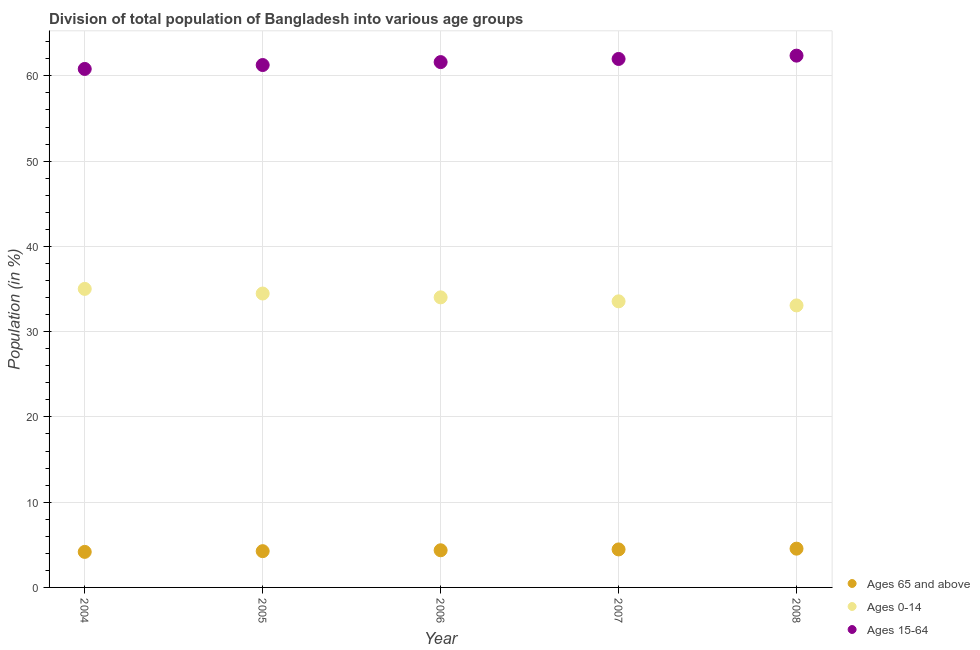How many different coloured dotlines are there?
Offer a very short reply. 3. Is the number of dotlines equal to the number of legend labels?
Keep it short and to the point. Yes. What is the percentage of population within the age-group 0-14 in 2007?
Your answer should be very brief. 33.56. Across all years, what is the maximum percentage of population within the age-group 15-64?
Offer a terse response. 62.38. Across all years, what is the minimum percentage of population within the age-group of 65 and above?
Your response must be concise. 4.17. In which year was the percentage of population within the age-group 15-64 maximum?
Offer a terse response. 2008. What is the total percentage of population within the age-group 0-14 in the graph?
Offer a very short reply. 170.15. What is the difference between the percentage of population within the age-group 0-14 in 2006 and that in 2007?
Your answer should be compact. 0.47. What is the difference between the percentage of population within the age-group 0-14 in 2006 and the percentage of population within the age-group of 65 and above in 2008?
Ensure brevity in your answer.  29.48. What is the average percentage of population within the age-group of 65 and above per year?
Your answer should be compact. 4.36. In the year 2005, what is the difference between the percentage of population within the age-group 15-64 and percentage of population within the age-group of 65 and above?
Your answer should be very brief. 57.02. In how many years, is the percentage of population within the age-group 0-14 greater than 52 %?
Provide a succinct answer. 0. What is the ratio of the percentage of population within the age-group 0-14 in 2005 to that in 2007?
Keep it short and to the point. 1.03. Is the percentage of population within the age-group 15-64 in 2004 less than that in 2005?
Ensure brevity in your answer.  Yes. Is the difference between the percentage of population within the age-group of 65 and above in 2004 and 2007 greater than the difference between the percentage of population within the age-group 15-64 in 2004 and 2007?
Offer a very short reply. Yes. What is the difference between the highest and the second highest percentage of population within the age-group 15-64?
Your response must be concise. 0.39. What is the difference between the highest and the lowest percentage of population within the age-group of 65 and above?
Your response must be concise. 0.38. Does the percentage of population within the age-group 0-14 monotonically increase over the years?
Provide a short and direct response. No. How many years are there in the graph?
Your answer should be compact. 5. Are the values on the major ticks of Y-axis written in scientific E-notation?
Give a very brief answer. No. Does the graph contain any zero values?
Provide a short and direct response. No. Does the graph contain grids?
Your response must be concise. Yes. Where does the legend appear in the graph?
Keep it short and to the point. Bottom right. How are the legend labels stacked?
Provide a short and direct response. Vertical. What is the title of the graph?
Offer a terse response. Division of total population of Bangladesh into various age groups
. What is the label or title of the X-axis?
Offer a terse response. Year. What is the label or title of the Y-axis?
Make the answer very short. Population (in %). What is the Population (in %) in Ages 65 and above in 2004?
Your response must be concise. 4.17. What is the Population (in %) of Ages 0-14 in 2004?
Keep it short and to the point. 35.02. What is the Population (in %) of Ages 15-64 in 2004?
Give a very brief answer. 60.81. What is the Population (in %) in Ages 65 and above in 2005?
Make the answer very short. 4.25. What is the Population (in %) in Ages 0-14 in 2005?
Your answer should be compact. 34.47. What is the Population (in %) of Ages 15-64 in 2005?
Give a very brief answer. 61.27. What is the Population (in %) in Ages 65 and above in 2006?
Give a very brief answer. 4.36. What is the Population (in %) of Ages 0-14 in 2006?
Offer a very short reply. 34.02. What is the Population (in %) in Ages 15-64 in 2006?
Your response must be concise. 61.62. What is the Population (in %) of Ages 65 and above in 2007?
Give a very brief answer. 4.46. What is the Population (in %) of Ages 0-14 in 2007?
Offer a terse response. 33.56. What is the Population (in %) of Ages 15-64 in 2007?
Keep it short and to the point. 61.99. What is the Population (in %) of Ages 65 and above in 2008?
Your answer should be compact. 4.55. What is the Population (in %) in Ages 0-14 in 2008?
Provide a short and direct response. 33.08. What is the Population (in %) in Ages 15-64 in 2008?
Your response must be concise. 62.38. Across all years, what is the maximum Population (in %) of Ages 65 and above?
Your answer should be compact. 4.55. Across all years, what is the maximum Population (in %) in Ages 0-14?
Offer a very short reply. 35.02. Across all years, what is the maximum Population (in %) in Ages 15-64?
Make the answer very short. 62.38. Across all years, what is the minimum Population (in %) of Ages 65 and above?
Your answer should be compact. 4.17. Across all years, what is the minimum Population (in %) in Ages 0-14?
Give a very brief answer. 33.08. Across all years, what is the minimum Population (in %) in Ages 15-64?
Make the answer very short. 60.81. What is the total Population (in %) in Ages 65 and above in the graph?
Give a very brief answer. 21.78. What is the total Population (in %) of Ages 0-14 in the graph?
Your response must be concise. 170.15. What is the total Population (in %) of Ages 15-64 in the graph?
Give a very brief answer. 308.07. What is the difference between the Population (in %) of Ages 65 and above in 2004 and that in 2005?
Offer a terse response. -0.08. What is the difference between the Population (in %) of Ages 0-14 in 2004 and that in 2005?
Give a very brief answer. 0.54. What is the difference between the Population (in %) in Ages 15-64 in 2004 and that in 2005?
Offer a very short reply. -0.46. What is the difference between the Population (in %) of Ages 65 and above in 2004 and that in 2006?
Your response must be concise. -0.19. What is the difference between the Population (in %) of Ages 0-14 in 2004 and that in 2006?
Your answer should be very brief. 0.99. What is the difference between the Population (in %) of Ages 15-64 in 2004 and that in 2006?
Provide a succinct answer. -0.8. What is the difference between the Population (in %) in Ages 65 and above in 2004 and that in 2007?
Provide a succinct answer. -0.29. What is the difference between the Population (in %) in Ages 0-14 in 2004 and that in 2007?
Make the answer very short. 1.46. What is the difference between the Population (in %) of Ages 15-64 in 2004 and that in 2007?
Make the answer very short. -1.17. What is the difference between the Population (in %) of Ages 65 and above in 2004 and that in 2008?
Your response must be concise. -0.38. What is the difference between the Population (in %) of Ages 0-14 in 2004 and that in 2008?
Offer a very short reply. 1.94. What is the difference between the Population (in %) in Ages 15-64 in 2004 and that in 2008?
Provide a succinct answer. -1.56. What is the difference between the Population (in %) of Ages 65 and above in 2005 and that in 2006?
Provide a short and direct response. -0.11. What is the difference between the Population (in %) of Ages 0-14 in 2005 and that in 2006?
Offer a very short reply. 0.45. What is the difference between the Population (in %) of Ages 15-64 in 2005 and that in 2006?
Ensure brevity in your answer.  -0.34. What is the difference between the Population (in %) of Ages 65 and above in 2005 and that in 2007?
Ensure brevity in your answer.  -0.2. What is the difference between the Population (in %) of Ages 0-14 in 2005 and that in 2007?
Give a very brief answer. 0.92. What is the difference between the Population (in %) in Ages 15-64 in 2005 and that in 2007?
Provide a short and direct response. -0.71. What is the difference between the Population (in %) in Ages 65 and above in 2005 and that in 2008?
Your answer should be compact. -0.29. What is the difference between the Population (in %) of Ages 0-14 in 2005 and that in 2008?
Make the answer very short. 1.4. What is the difference between the Population (in %) in Ages 15-64 in 2005 and that in 2008?
Provide a succinct answer. -1.1. What is the difference between the Population (in %) of Ages 65 and above in 2006 and that in 2007?
Provide a succinct answer. -0.1. What is the difference between the Population (in %) of Ages 0-14 in 2006 and that in 2007?
Keep it short and to the point. 0.47. What is the difference between the Population (in %) of Ages 15-64 in 2006 and that in 2007?
Offer a terse response. -0.37. What is the difference between the Population (in %) in Ages 65 and above in 2006 and that in 2008?
Provide a succinct answer. -0.19. What is the difference between the Population (in %) in Ages 0-14 in 2006 and that in 2008?
Your answer should be very brief. 0.95. What is the difference between the Population (in %) in Ages 15-64 in 2006 and that in 2008?
Your answer should be compact. -0.76. What is the difference between the Population (in %) of Ages 65 and above in 2007 and that in 2008?
Provide a succinct answer. -0.09. What is the difference between the Population (in %) of Ages 0-14 in 2007 and that in 2008?
Offer a very short reply. 0.48. What is the difference between the Population (in %) of Ages 15-64 in 2007 and that in 2008?
Provide a short and direct response. -0.39. What is the difference between the Population (in %) in Ages 65 and above in 2004 and the Population (in %) in Ages 0-14 in 2005?
Your response must be concise. -30.3. What is the difference between the Population (in %) in Ages 65 and above in 2004 and the Population (in %) in Ages 15-64 in 2005?
Give a very brief answer. -57.11. What is the difference between the Population (in %) of Ages 0-14 in 2004 and the Population (in %) of Ages 15-64 in 2005?
Make the answer very short. -26.26. What is the difference between the Population (in %) in Ages 65 and above in 2004 and the Population (in %) in Ages 0-14 in 2006?
Your response must be concise. -29.86. What is the difference between the Population (in %) in Ages 65 and above in 2004 and the Population (in %) in Ages 15-64 in 2006?
Keep it short and to the point. -57.45. What is the difference between the Population (in %) in Ages 0-14 in 2004 and the Population (in %) in Ages 15-64 in 2006?
Your response must be concise. -26.6. What is the difference between the Population (in %) in Ages 65 and above in 2004 and the Population (in %) in Ages 0-14 in 2007?
Offer a very short reply. -29.39. What is the difference between the Population (in %) in Ages 65 and above in 2004 and the Population (in %) in Ages 15-64 in 2007?
Offer a very short reply. -57.82. What is the difference between the Population (in %) in Ages 0-14 in 2004 and the Population (in %) in Ages 15-64 in 2007?
Provide a short and direct response. -26.97. What is the difference between the Population (in %) in Ages 65 and above in 2004 and the Population (in %) in Ages 0-14 in 2008?
Give a very brief answer. -28.91. What is the difference between the Population (in %) in Ages 65 and above in 2004 and the Population (in %) in Ages 15-64 in 2008?
Offer a terse response. -58.21. What is the difference between the Population (in %) in Ages 0-14 in 2004 and the Population (in %) in Ages 15-64 in 2008?
Offer a terse response. -27.36. What is the difference between the Population (in %) of Ages 65 and above in 2005 and the Population (in %) of Ages 0-14 in 2006?
Your answer should be very brief. -29.77. What is the difference between the Population (in %) in Ages 65 and above in 2005 and the Population (in %) in Ages 15-64 in 2006?
Your answer should be very brief. -57.36. What is the difference between the Population (in %) in Ages 0-14 in 2005 and the Population (in %) in Ages 15-64 in 2006?
Offer a very short reply. -27.14. What is the difference between the Population (in %) of Ages 65 and above in 2005 and the Population (in %) of Ages 0-14 in 2007?
Your response must be concise. -29.3. What is the difference between the Population (in %) of Ages 65 and above in 2005 and the Population (in %) of Ages 15-64 in 2007?
Offer a terse response. -57.73. What is the difference between the Population (in %) in Ages 0-14 in 2005 and the Population (in %) in Ages 15-64 in 2007?
Make the answer very short. -27.51. What is the difference between the Population (in %) in Ages 65 and above in 2005 and the Population (in %) in Ages 0-14 in 2008?
Your response must be concise. -28.82. What is the difference between the Population (in %) in Ages 65 and above in 2005 and the Population (in %) in Ages 15-64 in 2008?
Ensure brevity in your answer.  -58.12. What is the difference between the Population (in %) in Ages 0-14 in 2005 and the Population (in %) in Ages 15-64 in 2008?
Your response must be concise. -27.9. What is the difference between the Population (in %) in Ages 65 and above in 2006 and the Population (in %) in Ages 0-14 in 2007?
Offer a terse response. -29.2. What is the difference between the Population (in %) in Ages 65 and above in 2006 and the Population (in %) in Ages 15-64 in 2007?
Your answer should be compact. -57.63. What is the difference between the Population (in %) of Ages 0-14 in 2006 and the Population (in %) of Ages 15-64 in 2007?
Make the answer very short. -27.96. What is the difference between the Population (in %) in Ages 65 and above in 2006 and the Population (in %) in Ages 0-14 in 2008?
Your answer should be very brief. -28.72. What is the difference between the Population (in %) in Ages 65 and above in 2006 and the Population (in %) in Ages 15-64 in 2008?
Offer a very short reply. -58.02. What is the difference between the Population (in %) of Ages 0-14 in 2006 and the Population (in %) of Ages 15-64 in 2008?
Provide a short and direct response. -28.35. What is the difference between the Population (in %) in Ages 65 and above in 2007 and the Population (in %) in Ages 0-14 in 2008?
Provide a succinct answer. -28.62. What is the difference between the Population (in %) in Ages 65 and above in 2007 and the Population (in %) in Ages 15-64 in 2008?
Keep it short and to the point. -57.92. What is the difference between the Population (in %) in Ages 0-14 in 2007 and the Population (in %) in Ages 15-64 in 2008?
Ensure brevity in your answer.  -28.82. What is the average Population (in %) in Ages 65 and above per year?
Ensure brevity in your answer.  4.36. What is the average Population (in %) in Ages 0-14 per year?
Make the answer very short. 34.03. What is the average Population (in %) in Ages 15-64 per year?
Keep it short and to the point. 61.61. In the year 2004, what is the difference between the Population (in %) in Ages 65 and above and Population (in %) in Ages 0-14?
Your answer should be very brief. -30.85. In the year 2004, what is the difference between the Population (in %) in Ages 65 and above and Population (in %) in Ages 15-64?
Your answer should be compact. -56.65. In the year 2004, what is the difference between the Population (in %) of Ages 0-14 and Population (in %) of Ages 15-64?
Make the answer very short. -25.8. In the year 2005, what is the difference between the Population (in %) of Ages 65 and above and Population (in %) of Ages 0-14?
Your answer should be very brief. -30.22. In the year 2005, what is the difference between the Population (in %) in Ages 65 and above and Population (in %) in Ages 15-64?
Provide a short and direct response. -57.02. In the year 2005, what is the difference between the Population (in %) of Ages 0-14 and Population (in %) of Ages 15-64?
Your answer should be compact. -26.8. In the year 2006, what is the difference between the Population (in %) of Ages 65 and above and Population (in %) of Ages 0-14?
Give a very brief answer. -29.67. In the year 2006, what is the difference between the Population (in %) in Ages 65 and above and Population (in %) in Ages 15-64?
Keep it short and to the point. -57.26. In the year 2006, what is the difference between the Population (in %) of Ages 0-14 and Population (in %) of Ages 15-64?
Offer a terse response. -27.59. In the year 2007, what is the difference between the Population (in %) of Ages 65 and above and Population (in %) of Ages 0-14?
Offer a terse response. -29.1. In the year 2007, what is the difference between the Population (in %) of Ages 65 and above and Population (in %) of Ages 15-64?
Provide a short and direct response. -57.53. In the year 2007, what is the difference between the Population (in %) of Ages 0-14 and Population (in %) of Ages 15-64?
Your answer should be very brief. -28.43. In the year 2008, what is the difference between the Population (in %) in Ages 65 and above and Population (in %) in Ages 0-14?
Offer a very short reply. -28.53. In the year 2008, what is the difference between the Population (in %) in Ages 65 and above and Population (in %) in Ages 15-64?
Ensure brevity in your answer.  -57.83. In the year 2008, what is the difference between the Population (in %) in Ages 0-14 and Population (in %) in Ages 15-64?
Offer a terse response. -29.3. What is the ratio of the Population (in %) of Ages 65 and above in 2004 to that in 2005?
Your response must be concise. 0.98. What is the ratio of the Population (in %) of Ages 0-14 in 2004 to that in 2005?
Your answer should be very brief. 1.02. What is the ratio of the Population (in %) in Ages 15-64 in 2004 to that in 2005?
Ensure brevity in your answer.  0.99. What is the ratio of the Population (in %) of Ages 65 and above in 2004 to that in 2006?
Keep it short and to the point. 0.96. What is the ratio of the Population (in %) in Ages 0-14 in 2004 to that in 2006?
Keep it short and to the point. 1.03. What is the ratio of the Population (in %) of Ages 15-64 in 2004 to that in 2006?
Offer a terse response. 0.99. What is the ratio of the Population (in %) of Ages 65 and above in 2004 to that in 2007?
Give a very brief answer. 0.94. What is the ratio of the Population (in %) of Ages 0-14 in 2004 to that in 2007?
Keep it short and to the point. 1.04. What is the ratio of the Population (in %) in Ages 15-64 in 2004 to that in 2007?
Make the answer very short. 0.98. What is the ratio of the Population (in %) of Ages 65 and above in 2004 to that in 2008?
Give a very brief answer. 0.92. What is the ratio of the Population (in %) in Ages 0-14 in 2004 to that in 2008?
Offer a terse response. 1.06. What is the ratio of the Population (in %) in Ages 65 and above in 2005 to that in 2006?
Your response must be concise. 0.98. What is the ratio of the Population (in %) of Ages 0-14 in 2005 to that in 2006?
Give a very brief answer. 1.01. What is the ratio of the Population (in %) of Ages 15-64 in 2005 to that in 2006?
Provide a succinct answer. 0.99. What is the ratio of the Population (in %) of Ages 65 and above in 2005 to that in 2007?
Your answer should be compact. 0.95. What is the ratio of the Population (in %) of Ages 0-14 in 2005 to that in 2007?
Offer a terse response. 1.03. What is the ratio of the Population (in %) in Ages 15-64 in 2005 to that in 2007?
Ensure brevity in your answer.  0.99. What is the ratio of the Population (in %) in Ages 65 and above in 2005 to that in 2008?
Ensure brevity in your answer.  0.94. What is the ratio of the Population (in %) of Ages 0-14 in 2005 to that in 2008?
Offer a very short reply. 1.04. What is the ratio of the Population (in %) of Ages 15-64 in 2005 to that in 2008?
Ensure brevity in your answer.  0.98. What is the ratio of the Population (in %) of Ages 65 and above in 2006 to that in 2007?
Offer a very short reply. 0.98. What is the ratio of the Population (in %) in Ages 0-14 in 2006 to that in 2007?
Your response must be concise. 1.01. What is the ratio of the Population (in %) of Ages 65 and above in 2006 to that in 2008?
Your response must be concise. 0.96. What is the ratio of the Population (in %) of Ages 0-14 in 2006 to that in 2008?
Provide a succinct answer. 1.03. What is the ratio of the Population (in %) in Ages 15-64 in 2006 to that in 2008?
Your answer should be very brief. 0.99. What is the ratio of the Population (in %) in Ages 65 and above in 2007 to that in 2008?
Offer a very short reply. 0.98. What is the ratio of the Population (in %) in Ages 0-14 in 2007 to that in 2008?
Provide a short and direct response. 1.01. What is the ratio of the Population (in %) of Ages 15-64 in 2007 to that in 2008?
Offer a very short reply. 0.99. What is the difference between the highest and the second highest Population (in %) in Ages 65 and above?
Your response must be concise. 0.09. What is the difference between the highest and the second highest Population (in %) of Ages 0-14?
Ensure brevity in your answer.  0.54. What is the difference between the highest and the second highest Population (in %) of Ages 15-64?
Provide a short and direct response. 0.39. What is the difference between the highest and the lowest Population (in %) in Ages 65 and above?
Make the answer very short. 0.38. What is the difference between the highest and the lowest Population (in %) in Ages 0-14?
Your answer should be compact. 1.94. What is the difference between the highest and the lowest Population (in %) in Ages 15-64?
Make the answer very short. 1.56. 